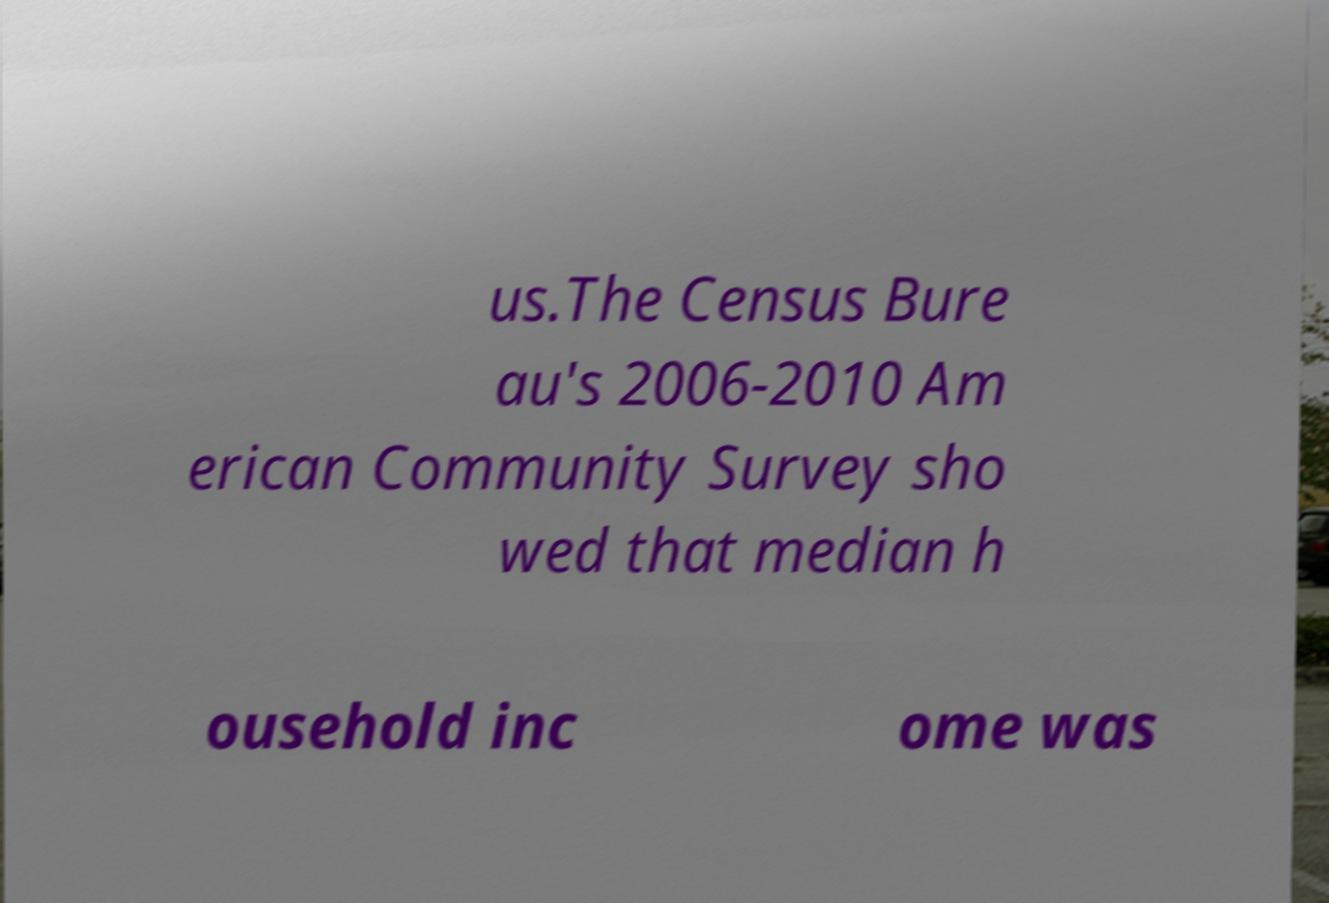Could you assist in decoding the text presented in this image and type it out clearly? us.The Census Bure au's 2006-2010 Am erican Community Survey sho wed that median h ousehold inc ome was 